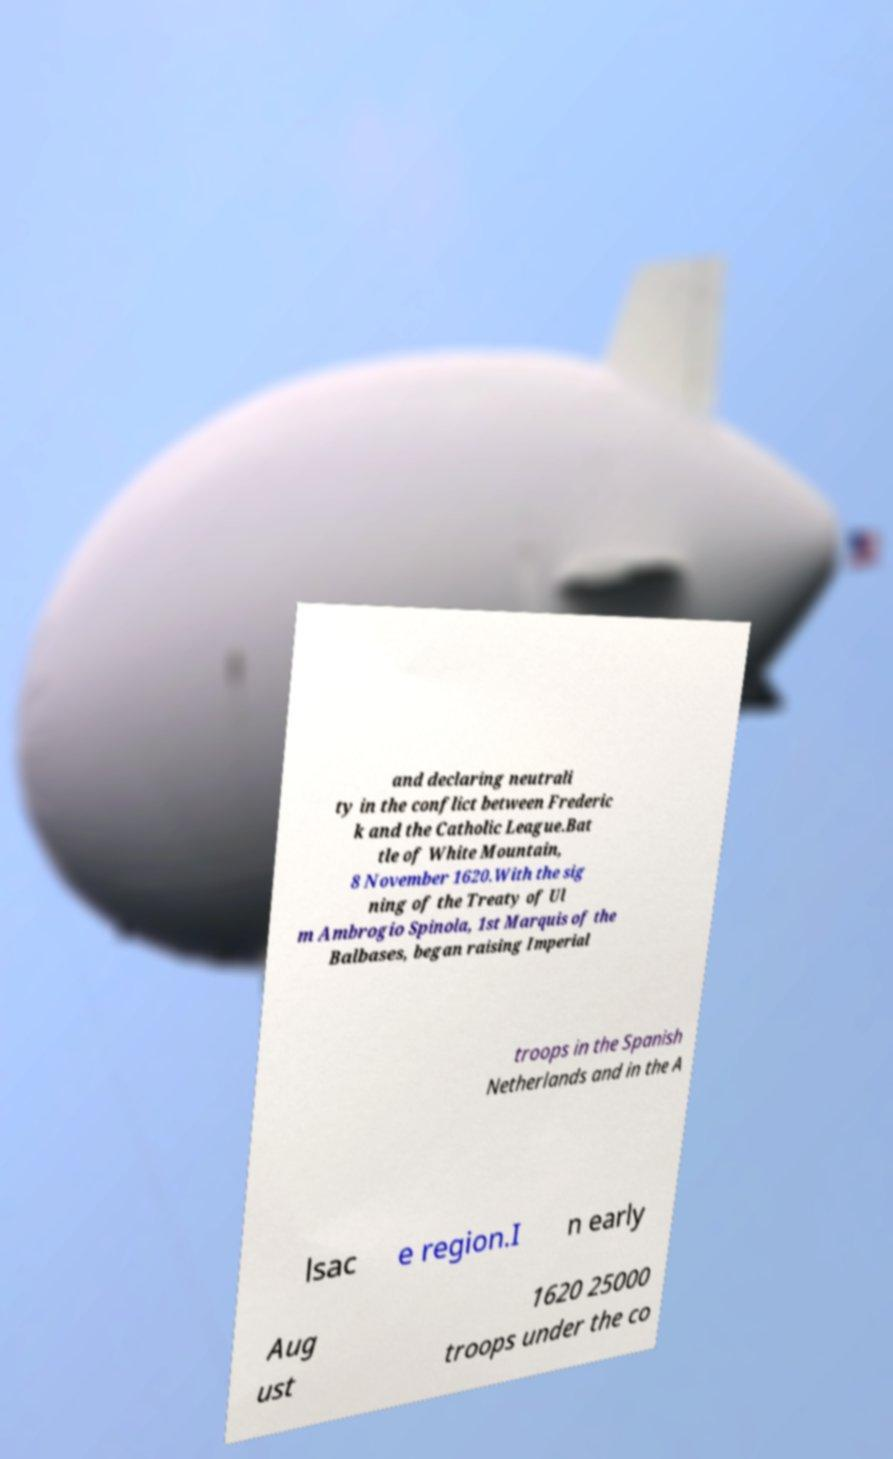Could you extract and type out the text from this image? and declaring neutrali ty in the conflict between Frederic k and the Catholic League.Bat tle of White Mountain, 8 November 1620.With the sig ning of the Treaty of Ul m Ambrogio Spinola, 1st Marquis of the Balbases, began raising Imperial troops in the Spanish Netherlands and in the A lsac e region.I n early Aug ust 1620 25000 troops under the co 